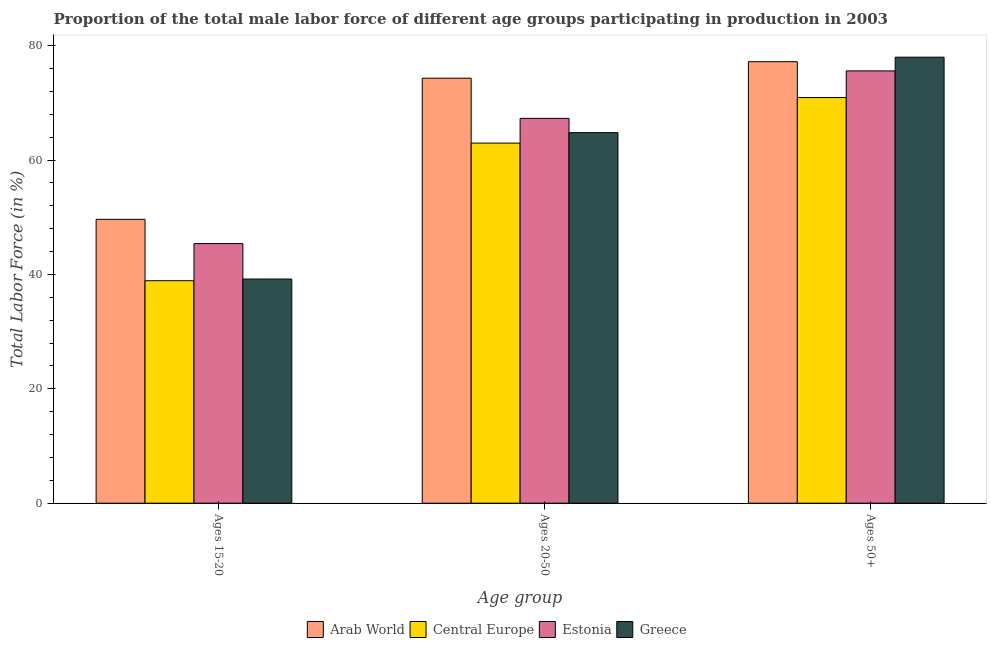How many different coloured bars are there?
Your answer should be compact. 4. Are the number of bars per tick equal to the number of legend labels?
Give a very brief answer. Yes. Are the number of bars on each tick of the X-axis equal?
Give a very brief answer. Yes. What is the label of the 1st group of bars from the left?
Offer a very short reply. Ages 15-20. What is the percentage of male labor force within the age group 15-20 in Central Europe?
Provide a short and direct response. 38.91. Across all countries, what is the maximum percentage of male labor force within the age group 20-50?
Your answer should be very brief. 74.33. Across all countries, what is the minimum percentage of male labor force within the age group 15-20?
Provide a short and direct response. 38.91. In which country was the percentage of male labor force within the age group 15-20 maximum?
Keep it short and to the point. Arab World. In which country was the percentage of male labor force above age 50 minimum?
Provide a short and direct response. Central Europe. What is the total percentage of male labor force within the age group 15-20 in the graph?
Make the answer very short. 173.15. What is the difference between the percentage of male labor force within the age group 20-50 in Central Europe and that in Greece?
Give a very brief answer. -1.83. What is the difference between the percentage of male labor force within the age group 20-50 in Estonia and the percentage of male labor force above age 50 in Greece?
Keep it short and to the point. -10.7. What is the average percentage of male labor force within the age group 20-50 per country?
Offer a very short reply. 67.35. What is the difference between the percentage of male labor force within the age group 20-50 and percentage of male labor force within the age group 15-20 in Greece?
Your response must be concise. 25.6. What is the ratio of the percentage of male labor force within the age group 15-20 in Central Europe to that in Greece?
Offer a very short reply. 0.99. What is the difference between the highest and the second highest percentage of male labor force within the age group 20-50?
Your answer should be compact. 7.03. What is the difference between the highest and the lowest percentage of male labor force within the age group 15-20?
Give a very brief answer. 10.74. Is the sum of the percentage of male labor force above age 50 in Estonia and Arab World greater than the maximum percentage of male labor force within the age group 15-20 across all countries?
Offer a terse response. Yes. What does the 2nd bar from the left in Ages 50+ represents?
Give a very brief answer. Central Europe. What does the 4th bar from the right in Ages 15-20 represents?
Keep it short and to the point. Arab World. Are the values on the major ticks of Y-axis written in scientific E-notation?
Keep it short and to the point. No. Does the graph contain grids?
Make the answer very short. No. How are the legend labels stacked?
Offer a very short reply. Horizontal. What is the title of the graph?
Your answer should be very brief. Proportion of the total male labor force of different age groups participating in production in 2003. What is the label or title of the X-axis?
Provide a succinct answer. Age group. What is the label or title of the Y-axis?
Give a very brief answer. Total Labor Force (in %). What is the Total Labor Force (in %) of Arab World in Ages 15-20?
Your answer should be very brief. 49.64. What is the Total Labor Force (in %) of Central Europe in Ages 15-20?
Give a very brief answer. 38.91. What is the Total Labor Force (in %) in Estonia in Ages 15-20?
Make the answer very short. 45.4. What is the Total Labor Force (in %) in Greece in Ages 15-20?
Give a very brief answer. 39.2. What is the Total Labor Force (in %) of Arab World in Ages 20-50?
Offer a very short reply. 74.33. What is the Total Labor Force (in %) of Central Europe in Ages 20-50?
Offer a terse response. 62.97. What is the Total Labor Force (in %) of Estonia in Ages 20-50?
Keep it short and to the point. 67.3. What is the Total Labor Force (in %) of Greece in Ages 20-50?
Your answer should be very brief. 64.8. What is the Total Labor Force (in %) in Arab World in Ages 50+?
Give a very brief answer. 77.21. What is the Total Labor Force (in %) of Central Europe in Ages 50+?
Make the answer very short. 70.94. What is the Total Labor Force (in %) of Estonia in Ages 50+?
Give a very brief answer. 75.6. What is the Total Labor Force (in %) of Greece in Ages 50+?
Provide a succinct answer. 78. Across all Age group, what is the maximum Total Labor Force (in %) of Arab World?
Offer a terse response. 77.21. Across all Age group, what is the maximum Total Labor Force (in %) in Central Europe?
Give a very brief answer. 70.94. Across all Age group, what is the maximum Total Labor Force (in %) of Estonia?
Ensure brevity in your answer.  75.6. Across all Age group, what is the maximum Total Labor Force (in %) of Greece?
Keep it short and to the point. 78. Across all Age group, what is the minimum Total Labor Force (in %) of Arab World?
Provide a short and direct response. 49.64. Across all Age group, what is the minimum Total Labor Force (in %) of Central Europe?
Your answer should be compact. 38.91. Across all Age group, what is the minimum Total Labor Force (in %) in Estonia?
Provide a short and direct response. 45.4. Across all Age group, what is the minimum Total Labor Force (in %) in Greece?
Make the answer very short. 39.2. What is the total Total Labor Force (in %) of Arab World in the graph?
Make the answer very short. 201.18. What is the total Total Labor Force (in %) of Central Europe in the graph?
Make the answer very short. 172.82. What is the total Total Labor Force (in %) of Estonia in the graph?
Ensure brevity in your answer.  188.3. What is the total Total Labor Force (in %) of Greece in the graph?
Offer a terse response. 182. What is the difference between the Total Labor Force (in %) in Arab World in Ages 15-20 and that in Ages 20-50?
Offer a terse response. -24.68. What is the difference between the Total Labor Force (in %) in Central Europe in Ages 15-20 and that in Ages 20-50?
Provide a succinct answer. -24.07. What is the difference between the Total Labor Force (in %) in Estonia in Ages 15-20 and that in Ages 20-50?
Give a very brief answer. -21.9. What is the difference between the Total Labor Force (in %) of Greece in Ages 15-20 and that in Ages 20-50?
Make the answer very short. -25.6. What is the difference between the Total Labor Force (in %) of Arab World in Ages 15-20 and that in Ages 50+?
Keep it short and to the point. -27.57. What is the difference between the Total Labor Force (in %) of Central Europe in Ages 15-20 and that in Ages 50+?
Make the answer very short. -32.04. What is the difference between the Total Labor Force (in %) in Estonia in Ages 15-20 and that in Ages 50+?
Your response must be concise. -30.2. What is the difference between the Total Labor Force (in %) in Greece in Ages 15-20 and that in Ages 50+?
Offer a very short reply. -38.8. What is the difference between the Total Labor Force (in %) in Arab World in Ages 20-50 and that in Ages 50+?
Provide a succinct answer. -2.88. What is the difference between the Total Labor Force (in %) of Central Europe in Ages 20-50 and that in Ages 50+?
Offer a terse response. -7.97. What is the difference between the Total Labor Force (in %) of Estonia in Ages 20-50 and that in Ages 50+?
Make the answer very short. -8.3. What is the difference between the Total Labor Force (in %) in Arab World in Ages 15-20 and the Total Labor Force (in %) in Central Europe in Ages 20-50?
Give a very brief answer. -13.33. What is the difference between the Total Labor Force (in %) of Arab World in Ages 15-20 and the Total Labor Force (in %) of Estonia in Ages 20-50?
Provide a succinct answer. -17.66. What is the difference between the Total Labor Force (in %) of Arab World in Ages 15-20 and the Total Labor Force (in %) of Greece in Ages 20-50?
Your answer should be compact. -15.16. What is the difference between the Total Labor Force (in %) in Central Europe in Ages 15-20 and the Total Labor Force (in %) in Estonia in Ages 20-50?
Your answer should be compact. -28.39. What is the difference between the Total Labor Force (in %) in Central Europe in Ages 15-20 and the Total Labor Force (in %) in Greece in Ages 20-50?
Make the answer very short. -25.89. What is the difference between the Total Labor Force (in %) of Estonia in Ages 15-20 and the Total Labor Force (in %) of Greece in Ages 20-50?
Ensure brevity in your answer.  -19.4. What is the difference between the Total Labor Force (in %) in Arab World in Ages 15-20 and the Total Labor Force (in %) in Central Europe in Ages 50+?
Offer a very short reply. -21.3. What is the difference between the Total Labor Force (in %) of Arab World in Ages 15-20 and the Total Labor Force (in %) of Estonia in Ages 50+?
Make the answer very short. -25.96. What is the difference between the Total Labor Force (in %) in Arab World in Ages 15-20 and the Total Labor Force (in %) in Greece in Ages 50+?
Offer a terse response. -28.36. What is the difference between the Total Labor Force (in %) in Central Europe in Ages 15-20 and the Total Labor Force (in %) in Estonia in Ages 50+?
Offer a very short reply. -36.69. What is the difference between the Total Labor Force (in %) in Central Europe in Ages 15-20 and the Total Labor Force (in %) in Greece in Ages 50+?
Your response must be concise. -39.09. What is the difference between the Total Labor Force (in %) of Estonia in Ages 15-20 and the Total Labor Force (in %) of Greece in Ages 50+?
Ensure brevity in your answer.  -32.6. What is the difference between the Total Labor Force (in %) of Arab World in Ages 20-50 and the Total Labor Force (in %) of Central Europe in Ages 50+?
Ensure brevity in your answer.  3.39. What is the difference between the Total Labor Force (in %) in Arab World in Ages 20-50 and the Total Labor Force (in %) in Estonia in Ages 50+?
Ensure brevity in your answer.  -1.27. What is the difference between the Total Labor Force (in %) of Arab World in Ages 20-50 and the Total Labor Force (in %) of Greece in Ages 50+?
Give a very brief answer. -3.67. What is the difference between the Total Labor Force (in %) in Central Europe in Ages 20-50 and the Total Labor Force (in %) in Estonia in Ages 50+?
Provide a short and direct response. -12.63. What is the difference between the Total Labor Force (in %) in Central Europe in Ages 20-50 and the Total Labor Force (in %) in Greece in Ages 50+?
Make the answer very short. -15.03. What is the average Total Labor Force (in %) in Arab World per Age group?
Offer a very short reply. 67.06. What is the average Total Labor Force (in %) of Central Europe per Age group?
Ensure brevity in your answer.  57.61. What is the average Total Labor Force (in %) in Estonia per Age group?
Keep it short and to the point. 62.77. What is the average Total Labor Force (in %) of Greece per Age group?
Offer a very short reply. 60.67. What is the difference between the Total Labor Force (in %) in Arab World and Total Labor Force (in %) in Central Europe in Ages 15-20?
Give a very brief answer. 10.74. What is the difference between the Total Labor Force (in %) of Arab World and Total Labor Force (in %) of Estonia in Ages 15-20?
Give a very brief answer. 4.24. What is the difference between the Total Labor Force (in %) of Arab World and Total Labor Force (in %) of Greece in Ages 15-20?
Offer a very short reply. 10.44. What is the difference between the Total Labor Force (in %) of Central Europe and Total Labor Force (in %) of Estonia in Ages 15-20?
Ensure brevity in your answer.  -6.49. What is the difference between the Total Labor Force (in %) of Central Europe and Total Labor Force (in %) of Greece in Ages 15-20?
Your answer should be very brief. -0.29. What is the difference between the Total Labor Force (in %) of Estonia and Total Labor Force (in %) of Greece in Ages 15-20?
Keep it short and to the point. 6.2. What is the difference between the Total Labor Force (in %) in Arab World and Total Labor Force (in %) in Central Europe in Ages 20-50?
Provide a short and direct response. 11.35. What is the difference between the Total Labor Force (in %) of Arab World and Total Labor Force (in %) of Estonia in Ages 20-50?
Ensure brevity in your answer.  7.03. What is the difference between the Total Labor Force (in %) of Arab World and Total Labor Force (in %) of Greece in Ages 20-50?
Ensure brevity in your answer.  9.53. What is the difference between the Total Labor Force (in %) in Central Europe and Total Labor Force (in %) in Estonia in Ages 20-50?
Make the answer very short. -4.33. What is the difference between the Total Labor Force (in %) of Central Europe and Total Labor Force (in %) of Greece in Ages 20-50?
Give a very brief answer. -1.83. What is the difference between the Total Labor Force (in %) in Estonia and Total Labor Force (in %) in Greece in Ages 20-50?
Give a very brief answer. 2.5. What is the difference between the Total Labor Force (in %) of Arab World and Total Labor Force (in %) of Central Europe in Ages 50+?
Give a very brief answer. 6.27. What is the difference between the Total Labor Force (in %) of Arab World and Total Labor Force (in %) of Estonia in Ages 50+?
Provide a short and direct response. 1.61. What is the difference between the Total Labor Force (in %) in Arab World and Total Labor Force (in %) in Greece in Ages 50+?
Offer a terse response. -0.79. What is the difference between the Total Labor Force (in %) in Central Europe and Total Labor Force (in %) in Estonia in Ages 50+?
Ensure brevity in your answer.  -4.66. What is the difference between the Total Labor Force (in %) of Central Europe and Total Labor Force (in %) of Greece in Ages 50+?
Your response must be concise. -7.06. What is the ratio of the Total Labor Force (in %) in Arab World in Ages 15-20 to that in Ages 20-50?
Offer a terse response. 0.67. What is the ratio of the Total Labor Force (in %) in Central Europe in Ages 15-20 to that in Ages 20-50?
Keep it short and to the point. 0.62. What is the ratio of the Total Labor Force (in %) of Estonia in Ages 15-20 to that in Ages 20-50?
Keep it short and to the point. 0.67. What is the ratio of the Total Labor Force (in %) in Greece in Ages 15-20 to that in Ages 20-50?
Provide a succinct answer. 0.6. What is the ratio of the Total Labor Force (in %) in Arab World in Ages 15-20 to that in Ages 50+?
Make the answer very short. 0.64. What is the ratio of the Total Labor Force (in %) in Central Europe in Ages 15-20 to that in Ages 50+?
Keep it short and to the point. 0.55. What is the ratio of the Total Labor Force (in %) of Estonia in Ages 15-20 to that in Ages 50+?
Ensure brevity in your answer.  0.6. What is the ratio of the Total Labor Force (in %) in Greece in Ages 15-20 to that in Ages 50+?
Make the answer very short. 0.5. What is the ratio of the Total Labor Force (in %) of Arab World in Ages 20-50 to that in Ages 50+?
Make the answer very short. 0.96. What is the ratio of the Total Labor Force (in %) of Central Europe in Ages 20-50 to that in Ages 50+?
Offer a very short reply. 0.89. What is the ratio of the Total Labor Force (in %) in Estonia in Ages 20-50 to that in Ages 50+?
Make the answer very short. 0.89. What is the ratio of the Total Labor Force (in %) in Greece in Ages 20-50 to that in Ages 50+?
Offer a terse response. 0.83. What is the difference between the highest and the second highest Total Labor Force (in %) in Arab World?
Keep it short and to the point. 2.88. What is the difference between the highest and the second highest Total Labor Force (in %) of Central Europe?
Ensure brevity in your answer.  7.97. What is the difference between the highest and the second highest Total Labor Force (in %) of Estonia?
Ensure brevity in your answer.  8.3. What is the difference between the highest and the second highest Total Labor Force (in %) in Greece?
Your response must be concise. 13.2. What is the difference between the highest and the lowest Total Labor Force (in %) of Arab World?
Your response must be concise. 27.57. What is the difference between the highest and the lowest Total Labor Force (in %) in Central Europe?
Your response must be concise. 32.04. What is the difference between the highest and the lowest Total Labor Force (in %) in Estonia?
Ensure brevity in your answer.  30.2. What is the difference between the highest and the lowest Total Labor Force (in %) in Greece?
Give a very brief answer. 38.8. 